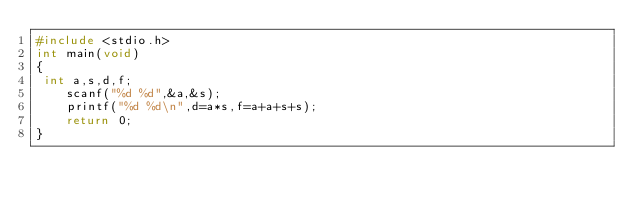<code> <loc_0><loc_0><loc_500><loc_500><_C_>#include <stdio.h>
int main(void)
{
 int a,s,d,f;
	scanf("%d %d",&a,&s);
	printf("%d %d\n",d=a*s,f=a+a+s+s);
	return 0;
}
</code> 